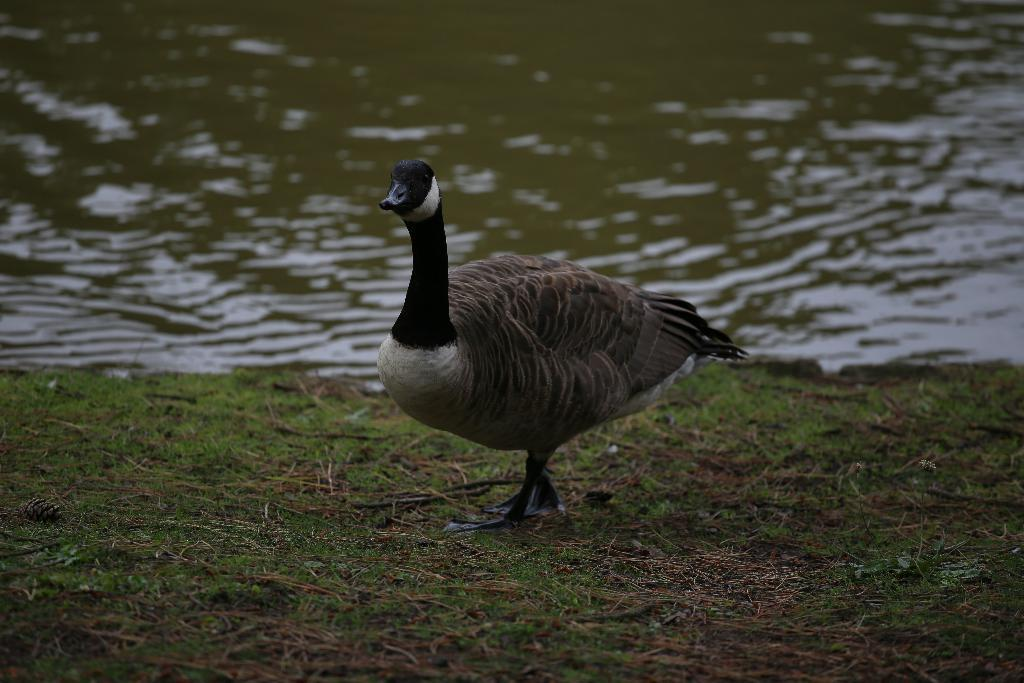What type of animal can be seen in the image? There is a bird in the image. Where is the bird located? The bird is standing on the grass. What can be seen in the background of the image? There is water visible in the background of the image. What type of crush does the bird have on its partner in the image? There is no indication in the image that the bird has a crush on a partner or any other emotions. 